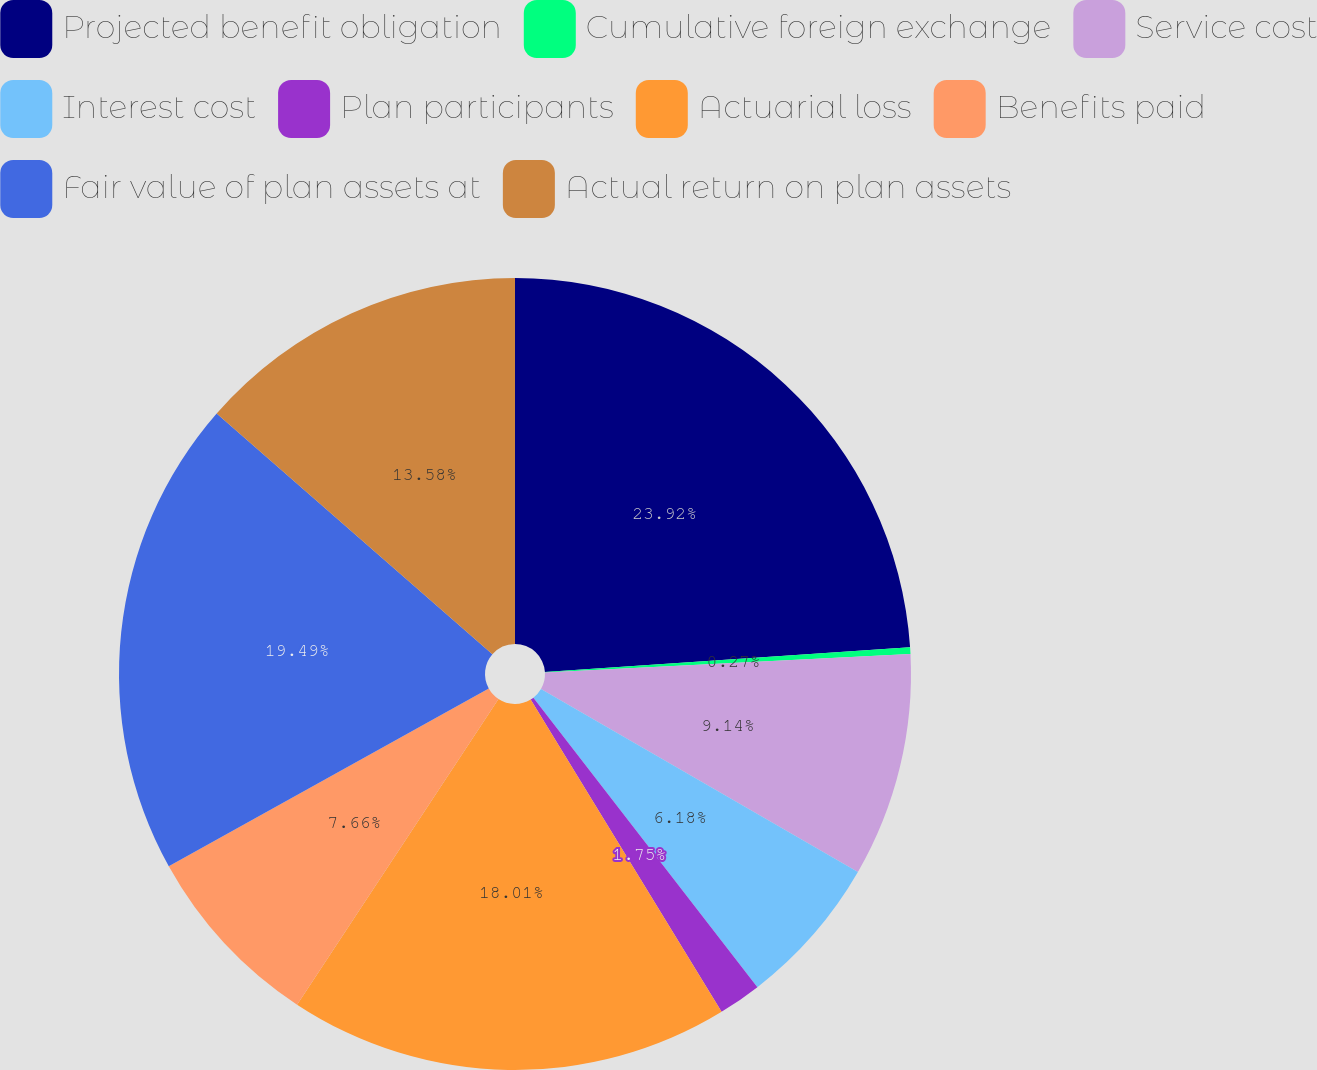Convert chart to OTSL. <chart><loc_0><loc_0><loc_500><loc_500><pie_chart><fcel>Projected benefit obligation<fcel>Cumulative foreign exchange<fcel>Service cost<fcel>Interest cost<fcel>Plan participants<fcel>Actuarial loss<fcel>Benefits paid<fcel>Fair value of plan assets at<fcel>Actual return on plan assets<nl><fcel>23.93%<fcel>0.27%<fcel>9.14%<fcel>6.18%<fcel>1.75%<fcel>18.01%<fcel>7.66%<fcel>19.49%<fcel>13.58%<nl></chart> 